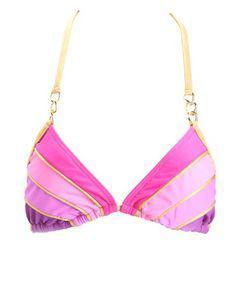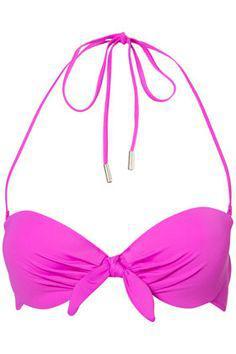The first image is the image on the left, the second image is the image on the right. Analyze the images presented: Is the assertion "At lease one of the swimsuits is pink." valid? Answer yes or no. Yes. 